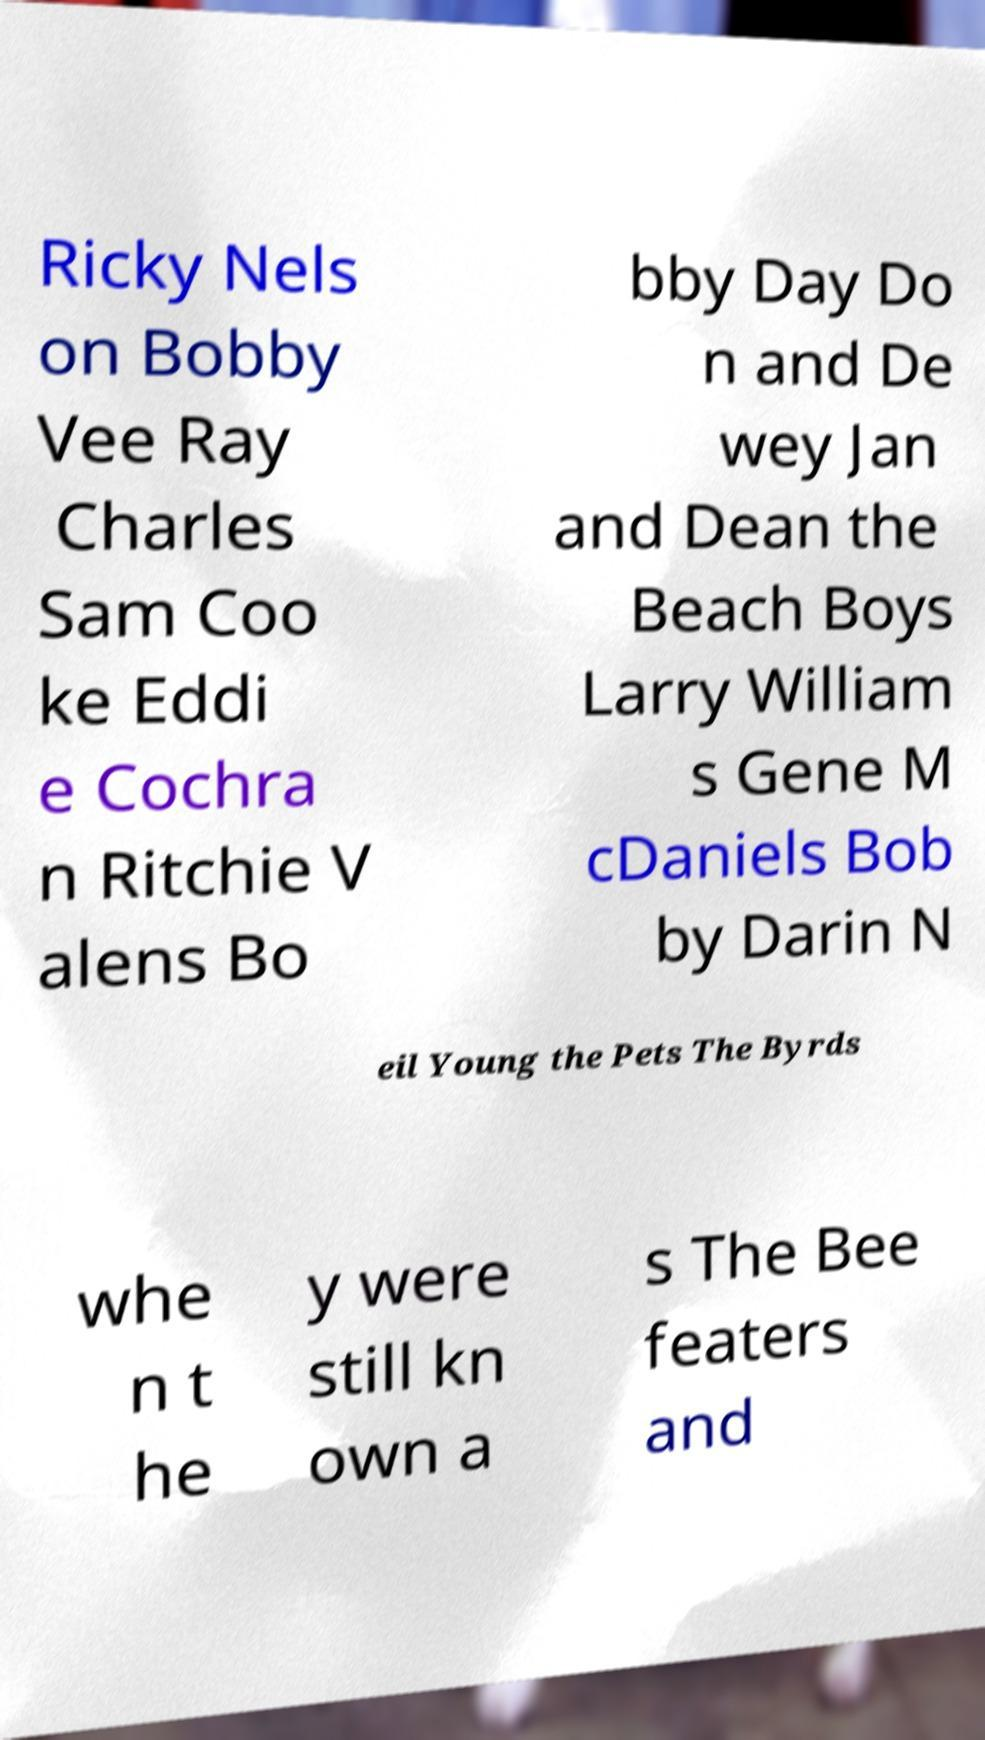Could you assist in decoding the text presented in this image and type it out clearly? Ricky Nels on Bobby Vee Ray Charles Sam Coo ke Eddi e Cochra n Ritchie V alens Bo bby Day Do n and De wey Jan and Dean the Beach Boys Larry William s Gene M cDaniels Bob by Darin N eil Young the Pets The Byrds whe n t he y were still kn own a s The Bee featers and 